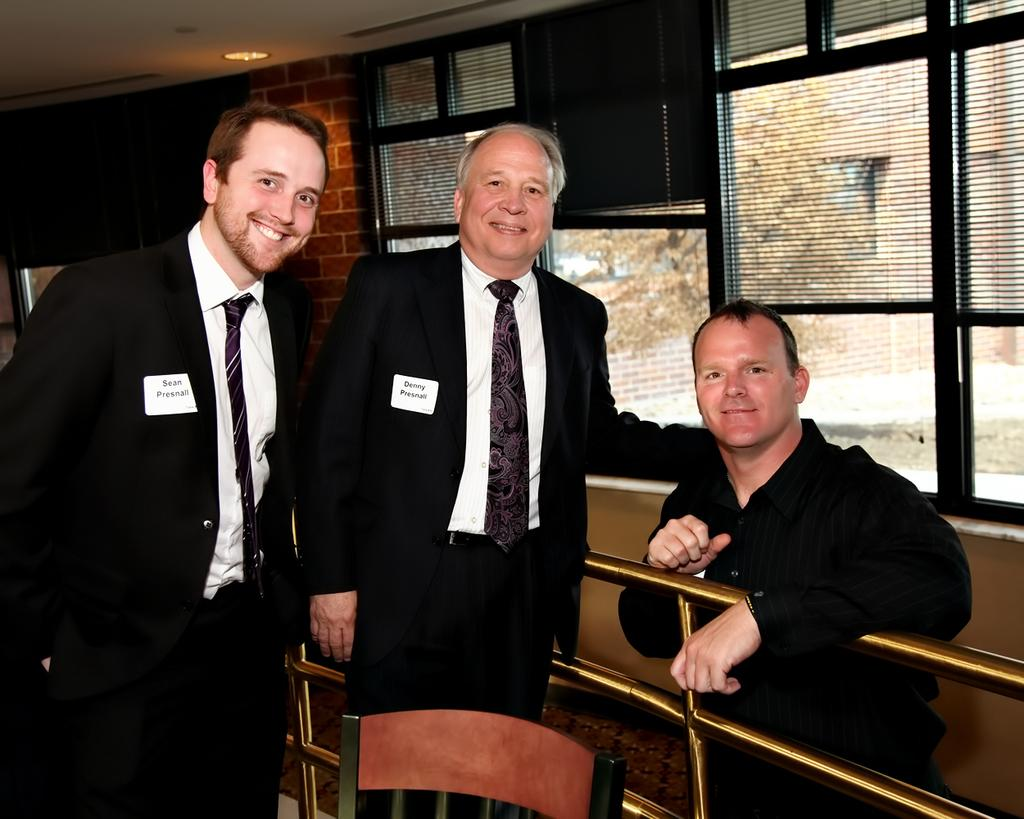How many men are in the image? There are three men in the image. What are the men wearing? The men are wearing black suits. What is located at the bottom of the image? There is a chair at the bottom of the image. What can be seen in the background of the image? There are windows and a wall visible in the background of the image. What type of trains can be seen passing by in the image? There are no trains visible in the image. What part of the brain is depicted in the image? There is no depiction of a brain in the image. 